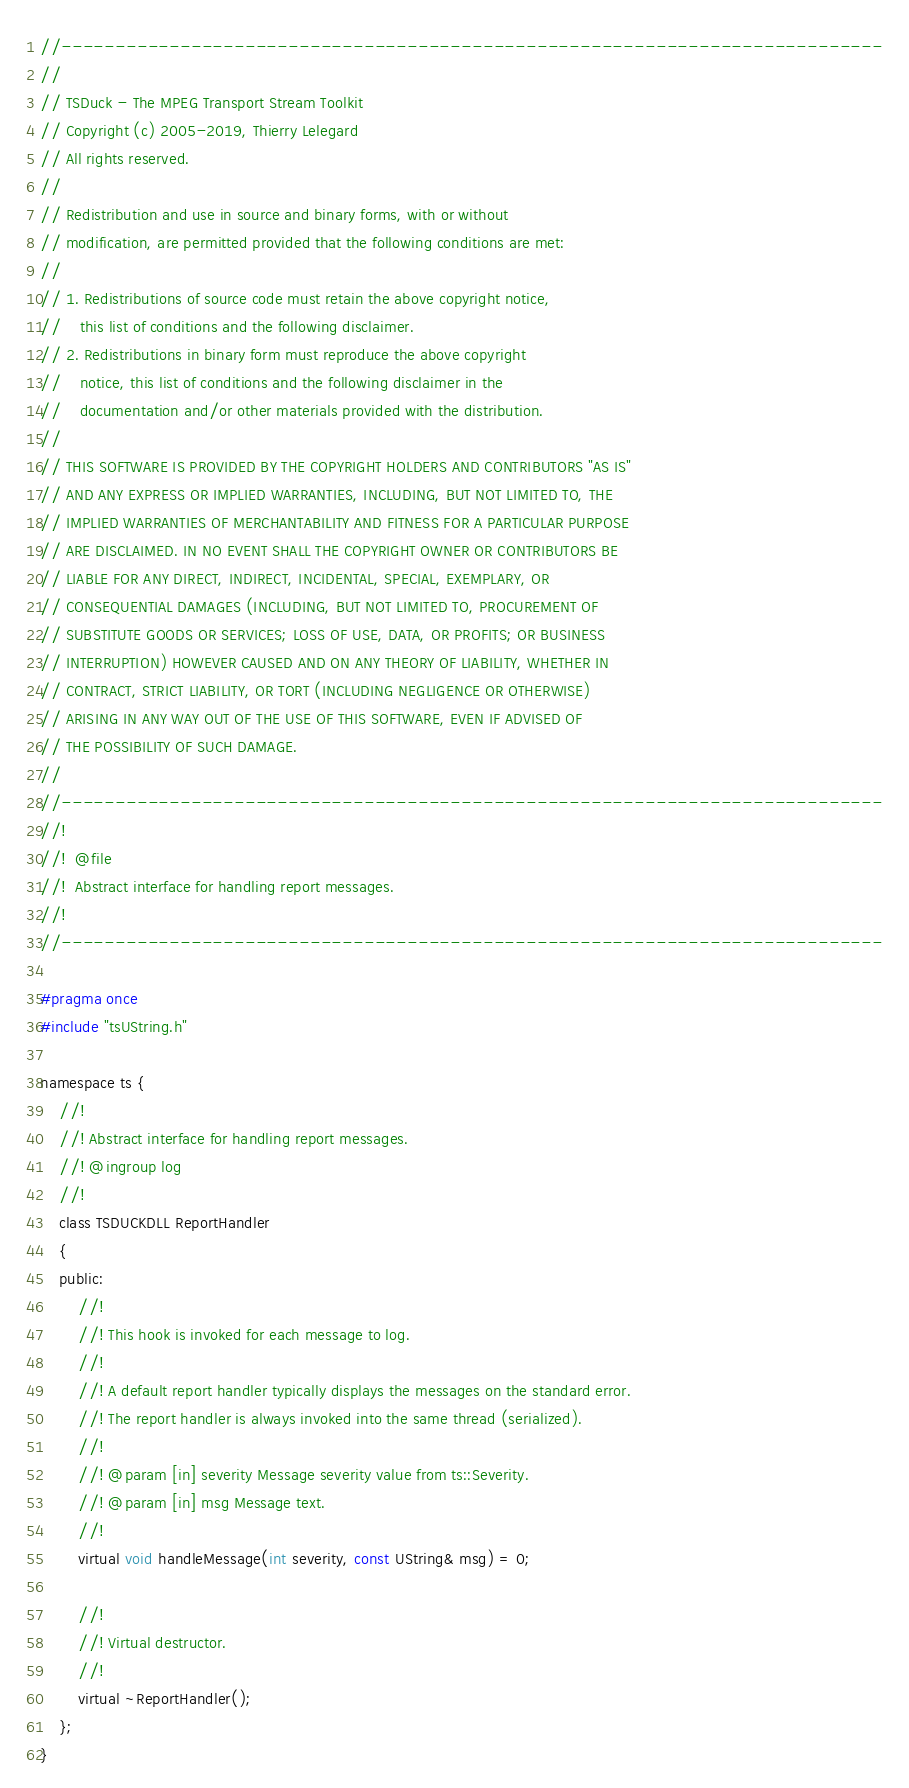<code> <loc_0><loc_0><loc_500><loc_500><_C_>//----------------------------------------------------------------------------
//
// TSDuck - The MPEG Transport Stream Toolkit
// Copyright (c) 2005-2019, Thierry Lelegard
// All rights reserved.
//
// Redistribution and use in source and binary forms, with or without
// modification, are permitted provided that the following conditions are met:
//
// 1. Redistributions of source code must retain the above copyright notice,
//    this list of conditions and the following disclaimer.
// 2. Redistributions in binary form must reproduce the above copyright
//    notice, this list of conditions and the following disclaimer in the
//    documentation and/or other materials provided with the distribution.
//
// THIS SOFTWARE IS PROVIDED BY THE COPYRIGHT HOLDERS AND CONTRIBUTORS "AS IS"
// AND ANY EXPRESS OR IMPLIED WARRANTIES, INCLUDING, BUT NOT LIMITED TO, THE
// IMPLIED WARRANTIES OF MERCHANTABILITY AND FITNESS FOR A PARTICULAR PURPOSE
// ARE DISCLAIMED. IN NO EVENT SHALL THE COPYRIGHT OWNER OR CONTRIBUTORS BE
// LIABLE FOR ANY DIRECT, INDIRECT, INCIDENTAL, SPECIAL, EXEMPLARY, OR
// CONSEQUENTIAL DAMAGES (INCLUDING, BUT NOT LIMITED TO, PROCUREMENT OF
// SUBSTITUTE GOODS OR SERVICES; LOSS OF USE, DATA, OR PROFITS; OR BUSINESS
// INTERRUPTION) HOWEVER CAUSED AND ON ANY THEORY OF LIABILITY, WHETHER IN
// CONTRACT, STRICT LIABILITY, OR TORT (INCLUDING NEGLIGENCE OR OTHERWISE)
// ARISING IN ANY WAY OUT OF THE USE OF THIS SOFTWARE, EVEN IF ADVISED OF
// THE POSSIBILITY OF SUCH DAMAGE.
//
//----------------------------------------------------------------------------
//!
//!  @file
//!  Abstract interface for handling report messages.
//!
//----------------------------------------------------------------------------

#pragma once
#include "tsUString.h"

namespace ts {
    //!
    //! Abstract interface for handling report messages.
    //! @ingroup log
    //!
    class TSDUCKDLL ReportHandler
    {
    public:
        //!
        //! This hook is invoked for each message to log.
        //!
        //! A default report handler typically displays the messages on the standard error.
        //! The report handler is always invoked into the same thread (serialized).
        //!
        //! @param [in] severity Message severity value from ts::Severity.
        //! @param [in] msg Message text.
        //!
        virtual void handleMessage(int severity, const UString& msg) = 0;

        //!
        //! Virtual destructor.
        //!
        virtual ~ReportHandler();
    };
}
</code> 